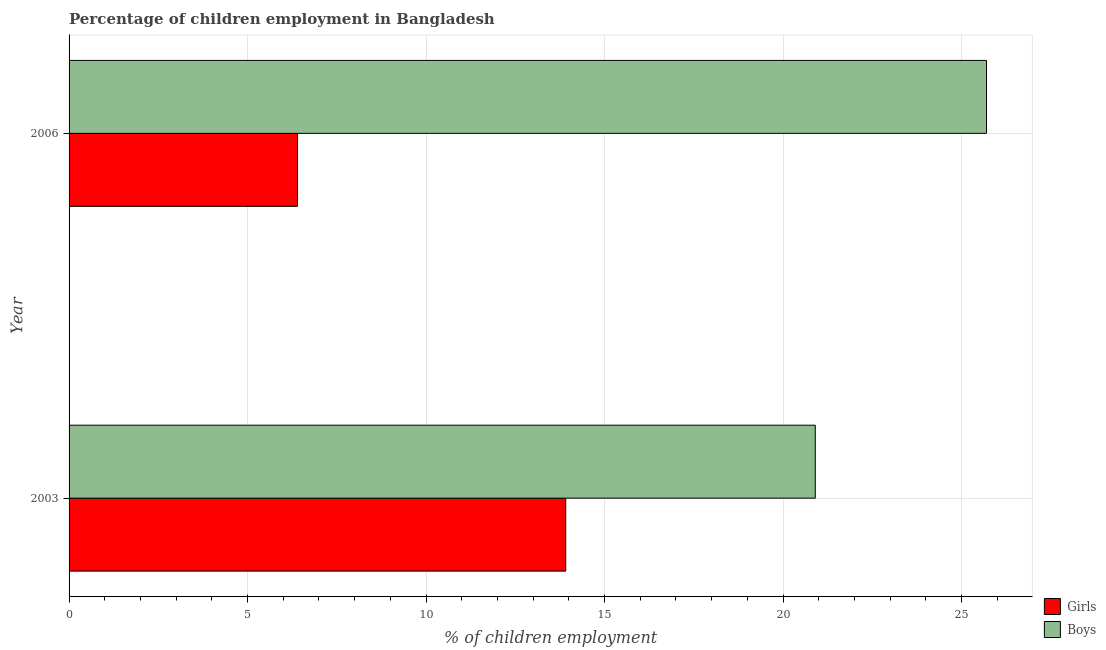Are the number of bars per tick equal to the number of legend labels?
Give a very brief answer. Yes. Are the number of bars on each tick of the Y-axis equal?
Offer a terse response. Yes. What is the label of the 1st group of bars from the top?
Provide a short and direct response. 2006. In how many cases, is the number of bars for a given year not equal to the number of legend labels?
Your answer should be very brief. 0. What is the percentage of employed boys in 2003?
Ensure brevity in your answer.  20.9. Across all years, what is the maximum percentage of employed girls?
Your answer should be very brief. 13.91. Across all years, what is the minimum percentage of employed boys?
Your answer should be very brief. 20.9. What is the total percentage of employed boys in the graph?
Your answer should be very brief. 46.6. What is the difference between the percentage of employed girls in 2003 and that in 2006?
Ensure brevity in your answer.  7.51. What is the difference between the percentage of employed girls in 2003 and the percentage of employed boys in 2006?
Offer a terse response. -11.79. What is the average percentage of employed boys per year?
Provide a short and direct response. 23.3. In the year 2006, what is the difference between the percentage of employed girls and percentage of employed boys?
Provide a short and direct response. -19.3. In how many years, is the percentage of employed girls greater than 3 %?
Ensure brevity in your answer.  2. What is the ratio of the percentage of employed girls in 2003 to that in 2006?
Your answer should be compact. 2.17. In how many years, is the percentage of employed girls greater than the average percentage of employed girls taken over all years?
Your answer should be compact. 1. What does the 1st bar from the top in 2006 represents?
Your answer should be very brief. Boys. What does the 2nd bar from the bottom in 2003 represents?
Offer a very short reply. Boys. How many years are there in the graph?
Your answer should be compact. 2. Are the values on the major ticks of X-axis written in scientific E-notation?
Make the answer very short. No. Does the graph contain any zero values?
Keep it short and to the point. No. Where does the legend appear in the graph?
Keep it short and to the point. Bottom right. What is the title of the graph?
Your answer should be compact. Percentage of children employment in Bangladesh. Does "Electricity and heat production" appear as one of the legend labels in the graph?
Provide a short and direct response. No. What is the label or title of the X-axis?
Ensure brevity in your answer.  % of children employment. What is the % of children employment in Girls in 2003?
Keep it short and to the point. 13.91. What is the % of children employment in Boys in 2003?
Offer a very short reply. 20.9. What is the % of children employment in Girls in 2006?
Make the answer very short. 6.4. What is the % of children employment in Boys in 2006?
Make the answer very short. 25.7. Across all years, what is the maximum % of children employment of Girls?
Provide a short and direct response. 13.91. Across all years, what is the maximum % of children employment of Boys?
Keep it short and to the point. 25.7. Across all years, what is the minimum % of children employment of Girls?
Your answer should be compact. 6.4. Across all years, what is the minimum % of children employment of Boys?
Your answer should be compact. 20.9. What is the total % of children employment of Girls in the graph?
Provide a succinct answer. 20.31. What is the total % of children employment in Boys in the graph?
Provide a short and direct response. 46.6. What is the difference between the % of children employment in Girls in 2003 and that in 2006?
Ensure brevity in your answer.  7.51. What is the difference between the % of children employment in Boys in 2003 and that in 2006?
Make the answer very short. -4.8. What is the difference between the % of children employment of Girls in 2003 and the % of children employment of Boys in 2006?
Offer a terse response. -11.79. What is the average % of children employment of Girls per year?
Provide a short and direct response. 10.16. What is the average % of children employment of Boys per year?
Make the answer very short. 23.3. In the year 2003, what is the difference between the % of children employment in Girls and % of children employment in Boys?
Your answer should be compact. -6.99. In the year 2006, what is the difference between the % of children employment of Girls and % of children employment of Boys?
Ensure brevity in your answer.  -19.3. What is the ratio of the % of children employment of Girls in 2003 to that in 2006?
Give a very brief answer. 2.17. What is the ratio of the % of children employment of Boys in 2003 to that in 2006?
Give a very brief answer. 0.81. What is the difference between the highest and the second highest % of children employment of Girls?
Your answer should be compact. 7.51. What is the difference between the highest and the second highest % of children employment of Boys?
Offer a very short reply. 4.8. What is the difference between the highest and the lowest % of children employment of Girls?
Offer a terse response. 7.51. What is the difference between the highest and the lowest % of children employment in Boys?
Ensure brevity in your answer.  4.8. 